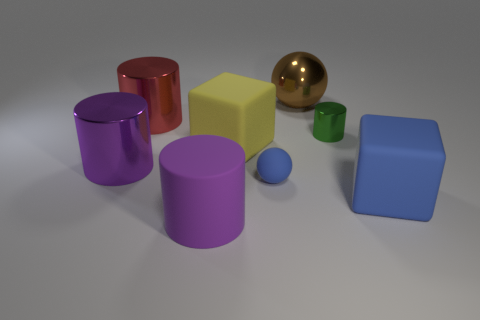Subtract all tiny green cylinders. How many cylinders are left? 3 Subtract all gray balls. How many purple cylinders are left? 2 Add 1 large brown metal spheres. How many objects exist? 9 Subtract all spheres. How many objects are left? 6 Subtract all red cylinders. How many cylinders are left? 3 Subtract all tiny green metal objects. Subtract all purple shiny objects. How many objects are left? 6 Add 2 brown metal spheres. How many brown metal spheres are left? 3 Add 3 big brown objects. How many big brown objects exist? 4 Subtract 1 green cylinders. How many objects are left? 7 Subtract all blue cylinders. Subtract all brown blocks. How many cylinders are left? 4 